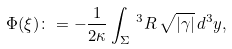<formula> <loc_0><loc_0><loc_500><loc_500>\Phi ( \xi ) \colon = - \frac { 1 } { 2 \kappa } \int _ { \Sigma } \, { ^ { 3 } } { R } \, \sqrt { | \gamma | } \, d ^ { 3 } y ,</formula> 